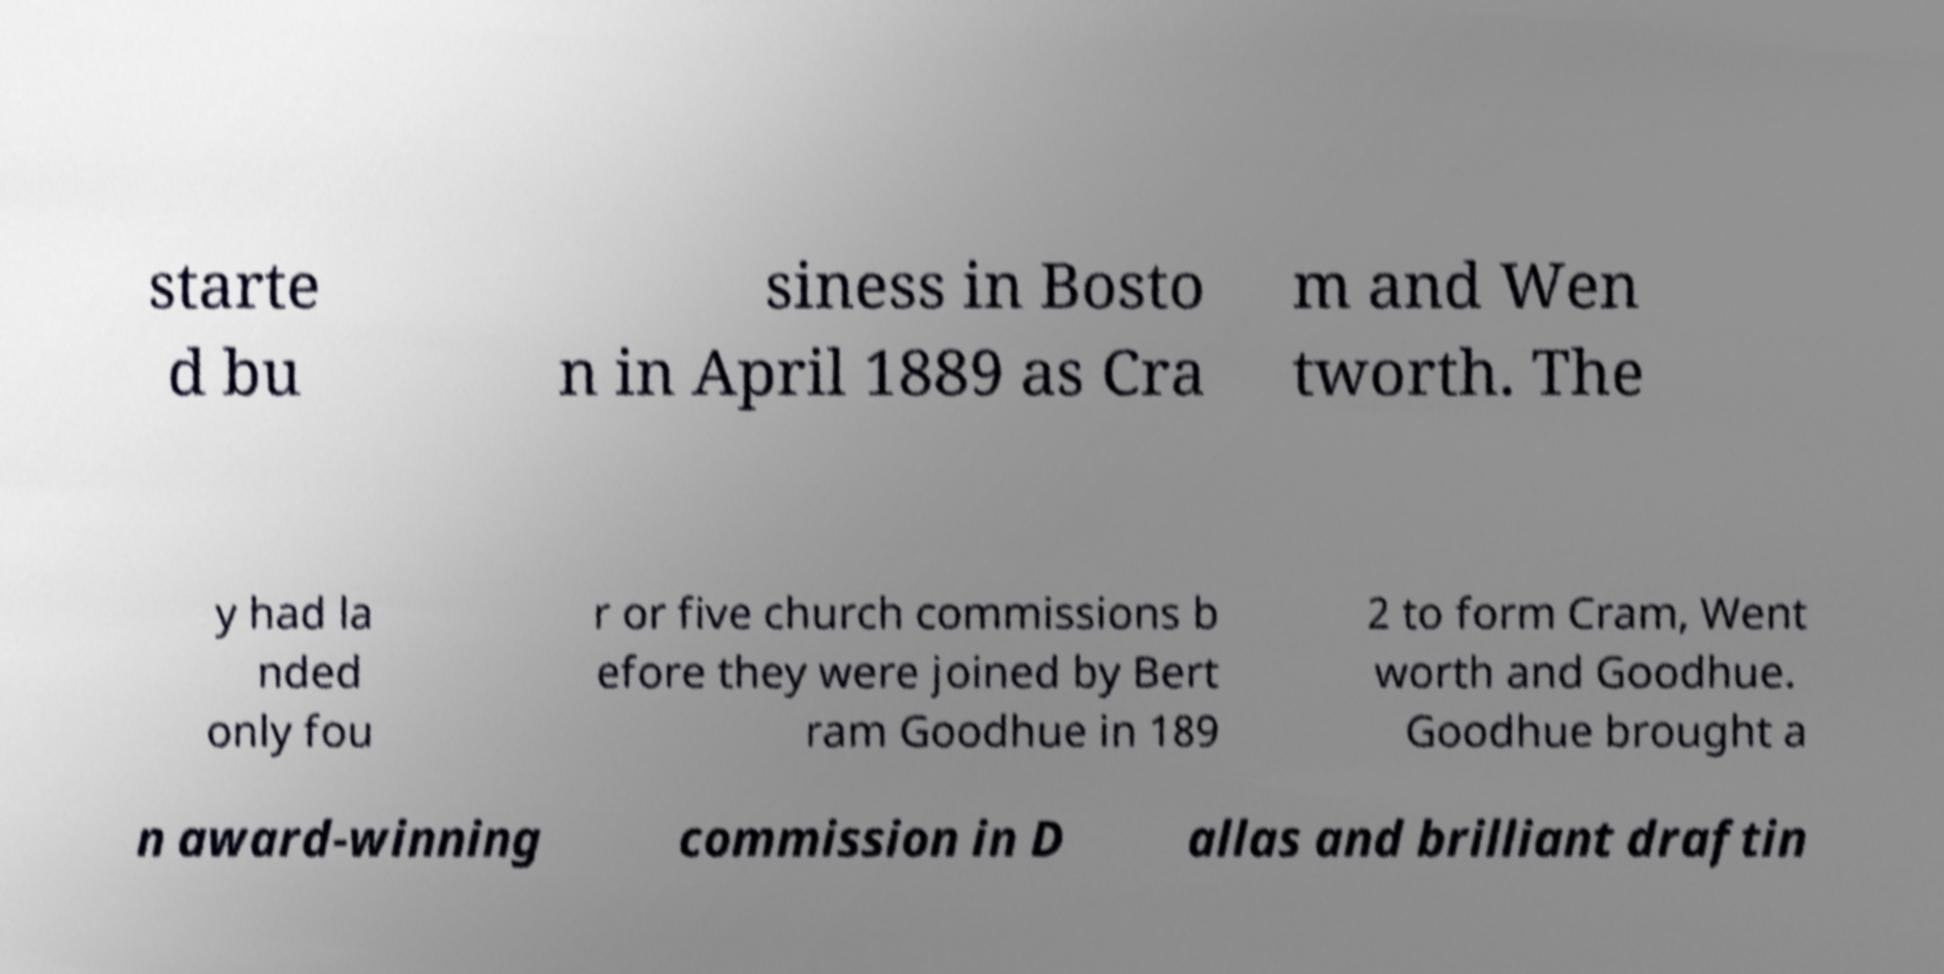Can you read and provide the text displayed in the image?This photo seems to have some interesting text. Can you extract and type it out for me? starte d bu siness in Bosto n in April 1889 as Cra m and Wen tworth. The y had la nded only fou r or five church commissions b efore they were joined by Bert ram Goodhue in 189 2 to form Cram, Went worth and Goodhue. Goodhue brought a n award-winning commission in D allas and brilliant draftin 